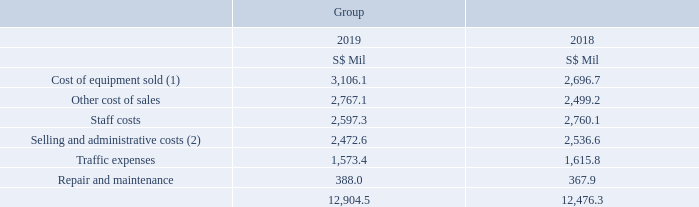5. Operating Expenses
Notes: (1) Includes equipment costs related to ICT services.
(2) Includes supplies and services, as well as rentals of properties and mobile base stations.
What is this the topic of this note 5? Operating expenses. What does cost of equipment sold include? Includes equipment costs related to ict services. What does selling and administrative costs include? Includes supplies and services, as well as rentals of properties and mobile base stations. In which year did Singtel had higher total operating expenses? 12,904.5 > 12,476.3
Answer: 2019. How many different type of operating expenses are there? Cost of equipment sold## Other cost of sales## Staff costs## Selling and administrative costs## Traffic Expenses## Repair and maintenance
Answer: 6. What is the average of the top 3 operating expenses subcategories in 2019?
Answer scale should be: million. (3,106.1 + 2,767.1 + 2,597.3) / 3
Answer: 2823.5. 